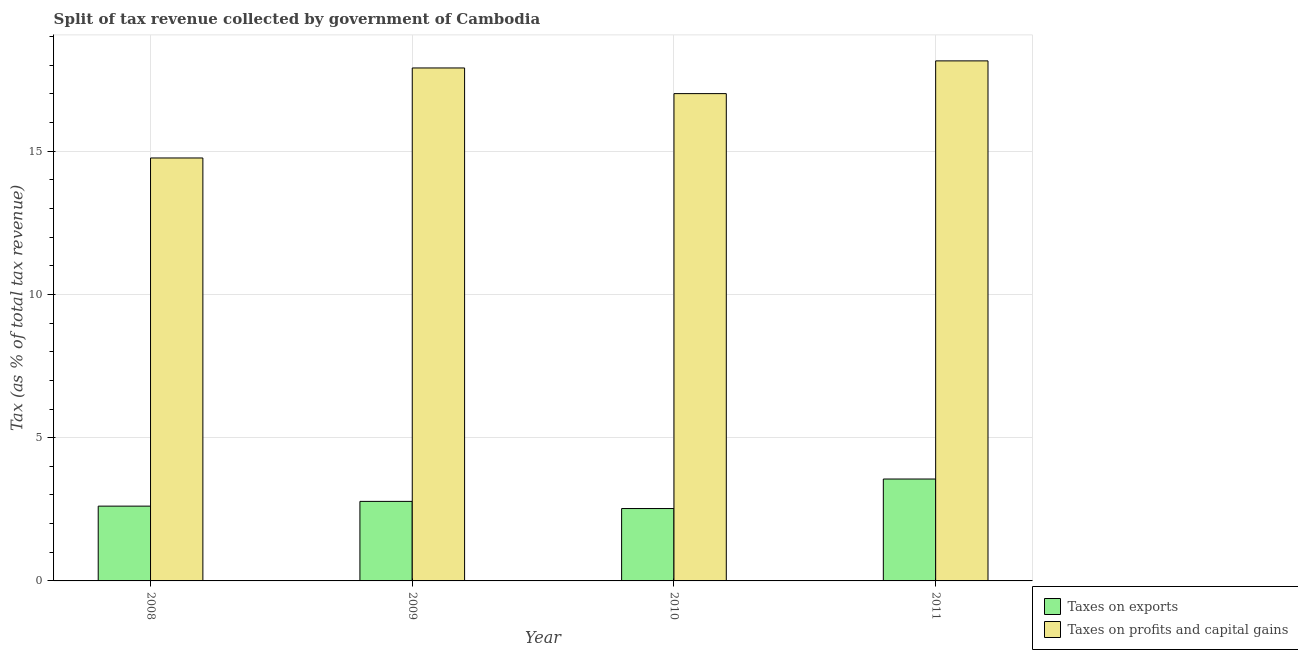How many different coloured bars are there?
Make the answer very short. 2. How many bars are there on the 2nd tick from the left?
Provide a short and direct response. 2. What is the label of the 4th group of bars from the left?
Your answer should be very brief. 2011. What is the percentage of revenue obtained from taxes on exports in 2008?
Offer a very short reply. 2.61. Across all years, what is the maximum percentage of revenue obtained from taxes on exports?
Ensure brevity in your answer.  3.56. Across all years, what is the minimum percentage of revenue obtained from taxes on profits and capital gains?
Give a very brief answer. 14.76. What is the total percentage of revenue obtained from taxes on exports in the graph?
Provide a succinct answer. 11.47. What is the difference between the percentage of revenue obtained from taxes on profits and capital gains in 2008 and that in 2010?
Offer a very short reply. -2.25. What is the difference between the percentage of revenue obtained from taxes on profits and capital gains in 2009 and the percentage of revenue obtained from taxes on exports in 2008?
Give a very brief answer. 3.14. What is the average percentage of revenue obtained from taxes on exports per year?
Your answer should be compact. 2.87. What is the ratio of the percentage of revenue obtained from taxes on profits and capital gains in 2008 to that in 2011?
Your answer should be very brief. 0.81. Is the percentage of revenue obtained from taxes on exports in 2008 less than that in 2011?
Keep it short and to the point. Yes. What is the difference between the highest and the second highest percentage of revenue obtained from taxes on exports?
Offer a very short reply. 0.78. What is the difference between the highest and the lowest percentage of revenue obtained from taxes on profits and capital gains?
Ensure brevity in your answer.  3.39. Is the sum of the percentage of revenue obtained from taxes on profits and capital gains in 2008 and 2010 greater than the maximum percentage of revenue obtained from taxes on exports across all years?
Give a very brief answer. Yes. What does the 2nd bar from the left in 2009 represents?
Your answer should be very brief. Taxes on profits and capital gains. What does the 1st bar from the right in 2011 represents?
Provide a short and direct response. Taxes on profits and capital gains. Are all the bars in the graph horizontal?
Provide a short and direct response. No. What is the difference between two consecutive major ticks on the Y-axis?
Give a very brief answer. 5. Does the graph contain any zero values?
Offer a terse response. No. Does the graph contain grids?
Provide a short and direct response. Yes. Where does the legend appear in the graph?
Make the answer very short. Bottom right. How are the legend labels stacked?
Your response must be concise. Vertical. What is the title of the graph?
Offer a terse response. Split of tax revenue collected by government of Cambodia. What is the label or title of the Y-axis?
Make the answer very short. Tax (as % of total tax revenue). What is the Tax (as % of total tax revenue) of Taxes on exports in 2008?
Your answer should be very brief. 2.61. What is the Tax (as % of total tax revenue) of Taxes on profits and capital gains in 2008?
Your response must be concise. 14.76. What is the Tax (as % of total tax revenue) of Taxes on exports in 2009?
Make the answer very short. 2.78. What is the Tax (as % of total tax revenue) of Taxes on profits and capital gains in 2009?
Offer a terse response. 17.9. What is the Tax (as % of total tax revenue) in Taxes on exports in 2010?
Provide a succinct answer. 2.53. What is the Tax (as % of total tax revenue) of Taxes on profits and capital gains in 2010?
Make the answer very short. 17.01. What is the Tax (as % of total tax revenue) of Taxes on exports in 2011?
Give a very brief answer. 3.56. What is the Tax (as % of total tax revenue) of Taxes on profits and capital gains in 2011?
Give a very brief answer. 18.15. Across all years, what is the maximum Tax (as % of total tax revenue) of Taxes on exports?
Your answer should be compact. 3.56. Across all years, what is the maximum Tax (as % of total tax revenue) in Taxes on profits and capital gains?
Offer a terse response. 18.15. Across all years, what is the minimum Tax (as % of total tax revenue) of Taxes on exports?
Your answer should be very brief. 2.53. Across all years, what is the minimum Tax (as % of total tax revenue) of Taxes on profits and capital gains?
Offer a very short reply. 14.76. What is the total Tax (as % of total tax revenue) of Taxes on exports in the graph?
Give a very brief answer. 11.47. What is the total Tax (as % of total tax revenue) of Taxes on profits and capital gains in the graph?
Make the answer very short. 67.82. What is the difference between the Tax (as % of total tax revenue) of Taxes on exports in 2008 and that in 2009?
Ensure brevity in your answer.  -0.17. What is the difference between the Tax (as % of total tax revenue) in Taxes on profits and capital gains in 2008 and that in 2009?
Your response must be concise. -3.14. What is the difference between the Tax (as % of total tax revenue) in Taxes on exports in 2008 and that in 2010?
Provide a short and direct response. 0.08. What is the difference between the Tax (as % of total tax revenue) in Taxes on profits and capital gains in 2008 and that in 2010?
Make the answer very short. -2.25. What is the difference between the Tax (as % of total tax revenue) in Taxes on exports in 2008 and that in 2011?
Ensure brevity in your answer.  -0.95. What is the difference between the Tax (as % of total tax revenue) of Taxes on profits and capital gains in 2008 and that in 2011?
Your answer should be compact. -3.39. What is the difference between the Tax (as % of total tax revenue) of Taxes on exports in 2009 and that in 2010?
Your answer should be very brief. 0.25. What is the difference between the Tax (as % of total tax revenue) in Taxes on profits and capital gains in 2009 and that in 2010?
Your answer should be compact. 0.9. What is the difference between the Tax (as % of total tax revenue) in Taxes on exports in 2009 and that in 2011?
Your answer should be very brief. -0.78. What is the difference between the Tax (as % of total tax revenue) of Taxes on profits and capital gains in 2009 and that in 2011?
Your response must be concise. -0.25. What is the difference between the Tax (as % of total tax revenue) of Taxes on exports in 2010 and that in 2011?
Ensure brevity in your answer.  -1.03. What is the difference between the Tax (as % of total tax revenue) of Taxes on profits and capital gains in 2010 and that in 2011?
Offer a very short reply. -1.14. What is the difference between the Tax (as % of total tax revenue) of Taxes on exports in 2008 and the Tax (as % of total tax revenue) of Taxes on profits and capital gains in 2009?
Your answer should be very brief. -15.29. What is the difference between the Tax (as % of total tax revenue) in Taxes on exports in 2008 and the Tax (as % of total tax revenue) in Taxes on profits and capital gains in 2010?
Provide a short and direct response. -14.4. What is the difference between the Tax (as % of total tax revenue) of Taxes on exports in 2008 and the Tax (as % of total tax revenue) of Taxes on profits and capital gains in 2011?
Your answer should be compact. -15.54. What is the difference between the Tax (as % of total tax revenue) in Taxes on exports in 2009 and the Tax (as % of total tax revenue) in Taxes on profits and capital gains in 2010?
Your answer should be compact. -14.23. What is the difference between the Tax (as % of total tax revenue) of Taxes on exports in 2009 and the Tax (as % of total tax revenue) of Taxes on profits and capital gains in 2011?
Your answer should be very brief. -15.37. What is the difference between the Tax (as % of total tax revenue) in Taxes on exports in 2010 and the Tax (as % of total tax revenue) in Taxes on profits and capital gains in 2011?
Make the answer very short. -15.62. What is the average Tax (as % of total tax revenue) of Taxes on exports per year?
Your response must be concise. 2.87. What is the average Tax (as % of total tax revenue) of Taxes on profits and capital gains per year?
Give a very brief answer. 16.95. In the year 2008, what is the difference between the Tax (as % of total tax revenue) in Taxes on exports and Tax (as % of total tax revenue) in Taxes on profits and capital gains?
Your answer should be compact. -12.15. In the year 2009, what is the difference between the Tax (as % of total tax revenue) of Taxes on exports and Tax (as % of total tax revenue) of Taxes on profits and capital gains?
Make the answer very short. -15.13. In the year 2010, what is the difference between the Tax (as % of total tax revenue) in Taxes on exports and Tax (as % of total tax revenue) in Taxes on profits and capital gains?
Keep it short and to the point. -14.48. In the year 2011, what is the difference between the Tax (as % of total tax revenue) of Taxes on exports and Tax (as % of total tax revenue) of Taxes on profits and capital gains?
Ensure brevity in your answer.  -14.59. What is the ratio of the Tax (as % of total tax revenue) of Taxes on exports in 2008 to that in 2009?
Provide a succinct answer. 0.94. What is the ratio of the Tax (as % of total tax revenue) in Taxes on profits and capital gains in 2008 to that in 2009?
Your response must be concise. 0.82. What is the ratio of the Tax (as % of total tax revenue) in Taxes on exports in 2008 to that in 2010?
Your answer should be compact. 1.03. What is the ratio of the Tax (as % of total tax revenue) in Taxes on profits and capital gains in 2008 to that in 2010?
Your response must be concise. 0.87. What is the ratio of the Tax (as % of total tax revenue) of Taxes on exports in 2008 to that in 2011?
Provide a short and direct response. 0.73. What is the ratio of the Tax (as % of total tax revenue) in Taxes on profits and capital gains in 2008 to that in 2011?
Provide a succinct answer. 0.81. What is the ratio of the Tax (as % of total tax revenue) of Taxes on exports in 2009 to that in 2010?
Your answer should be compact. 1.1. What is the ratio of the Tax (as % of total tax revenue) of Taxes on profits and capital gains in 2009 to that in 2010?
Your answer should be compact. 1.05. What is the ratio of the Tax (as % of total tax revenue) in Taxes on exports in 2009 to that in 2011?
Make the answer very short. 0.78. What is the ratio of the Tax (as % of total tax revenue) in Taxes on profits and capital gains in 2009 to that in 2011?
Keep it short and to the point. 0.99. What is the ratio of the Tax (as % of total tax revenue) in Taxes on exports in 2010 to that in 2011?
Give a very brief answer. 0.71. What is the ratio of the Tax (as % of total tax revenue) of Taxes on profits and capital gains in 2010 to that in 2011?
Make the answer very short. 0.94. What is the difference between the highest and the second highest Tax (as % of total tax revenue) in Taxes on exports?
Offer a terse response. 0.78. What is the difference between the highest and the second highest Tax (as % of total tax revenue) of Taxes on profits and capital gains?
Offer a terse response. 0.25. What is the difference between the highest and the lowest Tax (as % of total tax revenue) in Taxes on profits and capital gains?
Your response must be concise. 3.39. 